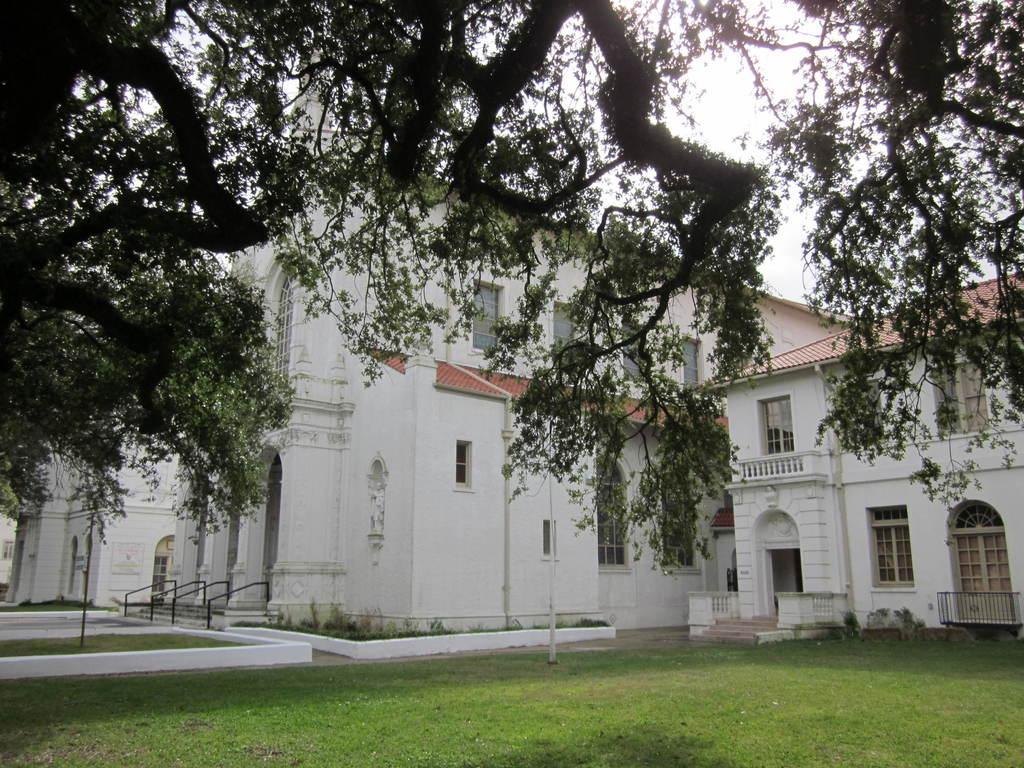In one or two sentences, can you explain what this image depicts? In the center of the image there is a house. At the bottom of the image there is grass. At the top of the image there is a tree branch. 